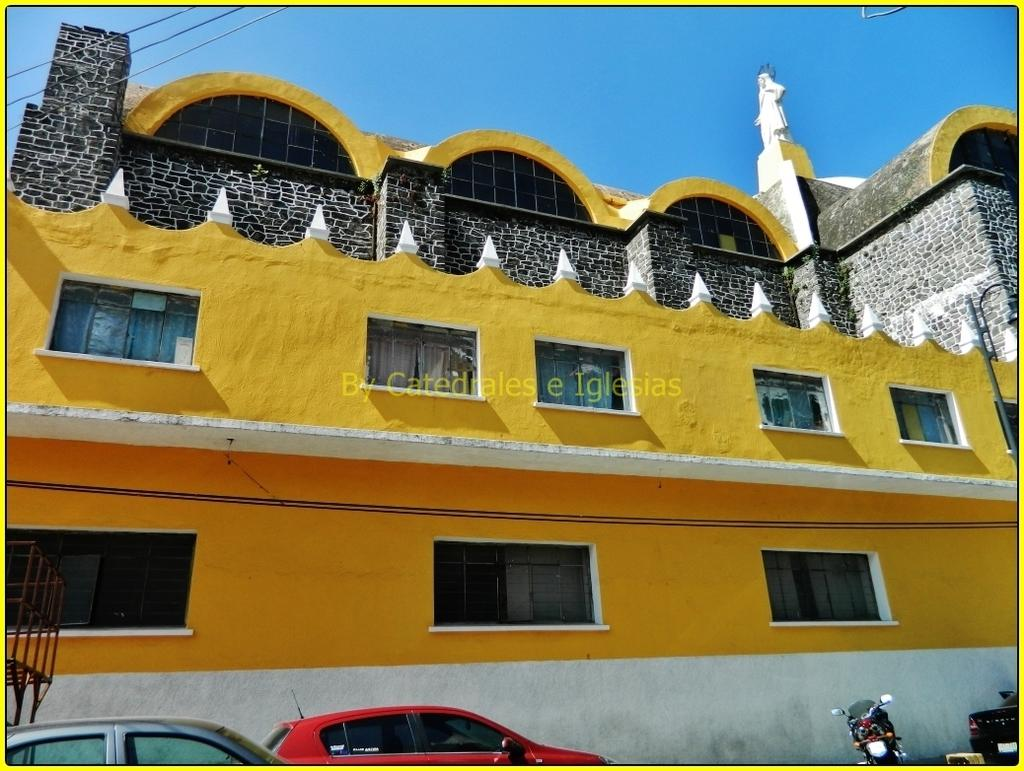What type of structure is in the image? There is a building in the image. What feature can be seen on the building? The building has windows. What color is the building? The building is yellow. How many cars are parked on the road in the image? There are three cars parked on the road. What other vehicle can be seen on the road? There is a bike parked on the road. What is visible in the background of the image? The sky is visible in the image. What color is the sky? The sky is blue. What type of toys can be seen in the zoo in the image? There is no zoo or toys present in the image; it features a yellow building, cars, a bike, and a blue sky. 